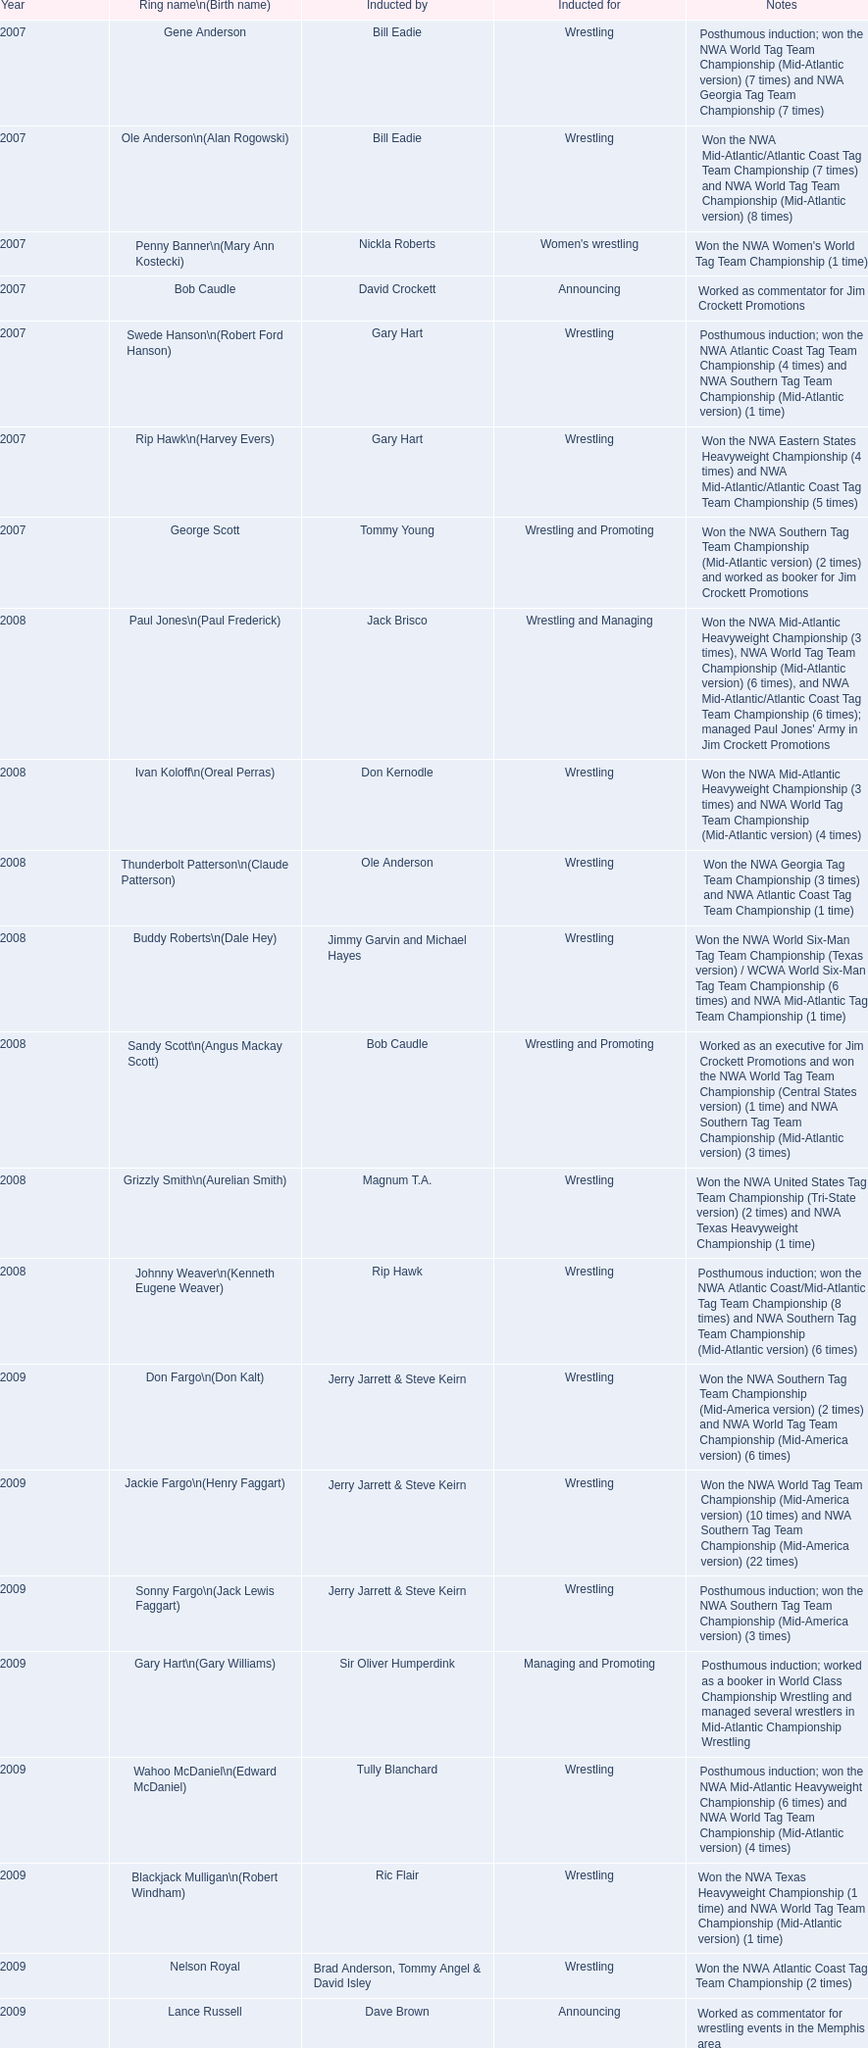During which year was the induction ceremony held? 2007. Which inductee was no longer living? Gene Anderson. 